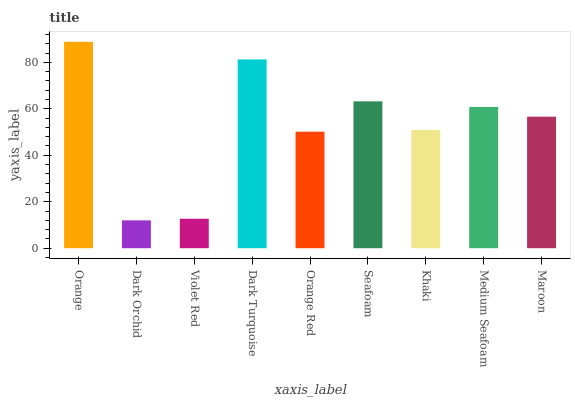Is Violet Red the minimum?
Answer yes or no. No. Is Violet Red the maximum?
Answer yes or no. No. Is Violet Red greater than Dark Orchid?
Answer yes or no. Yes. Is Dark Orchid less than Violet Red?
Answer yes or no. Yes. Is Dark Orchid greater than Violet Red?
Answer yes or no. No. Is Violet Red less than Dark Orchid?
Answer yes or no. No. Is Maroon the high median?
Answer yes or no. Yes. Is Maroon the low median?
Answer yes or no. Yes. Is Violet Red the high median?
Answer yes or no. No. Is Khaki the low median?
Answer yes or no. No. 